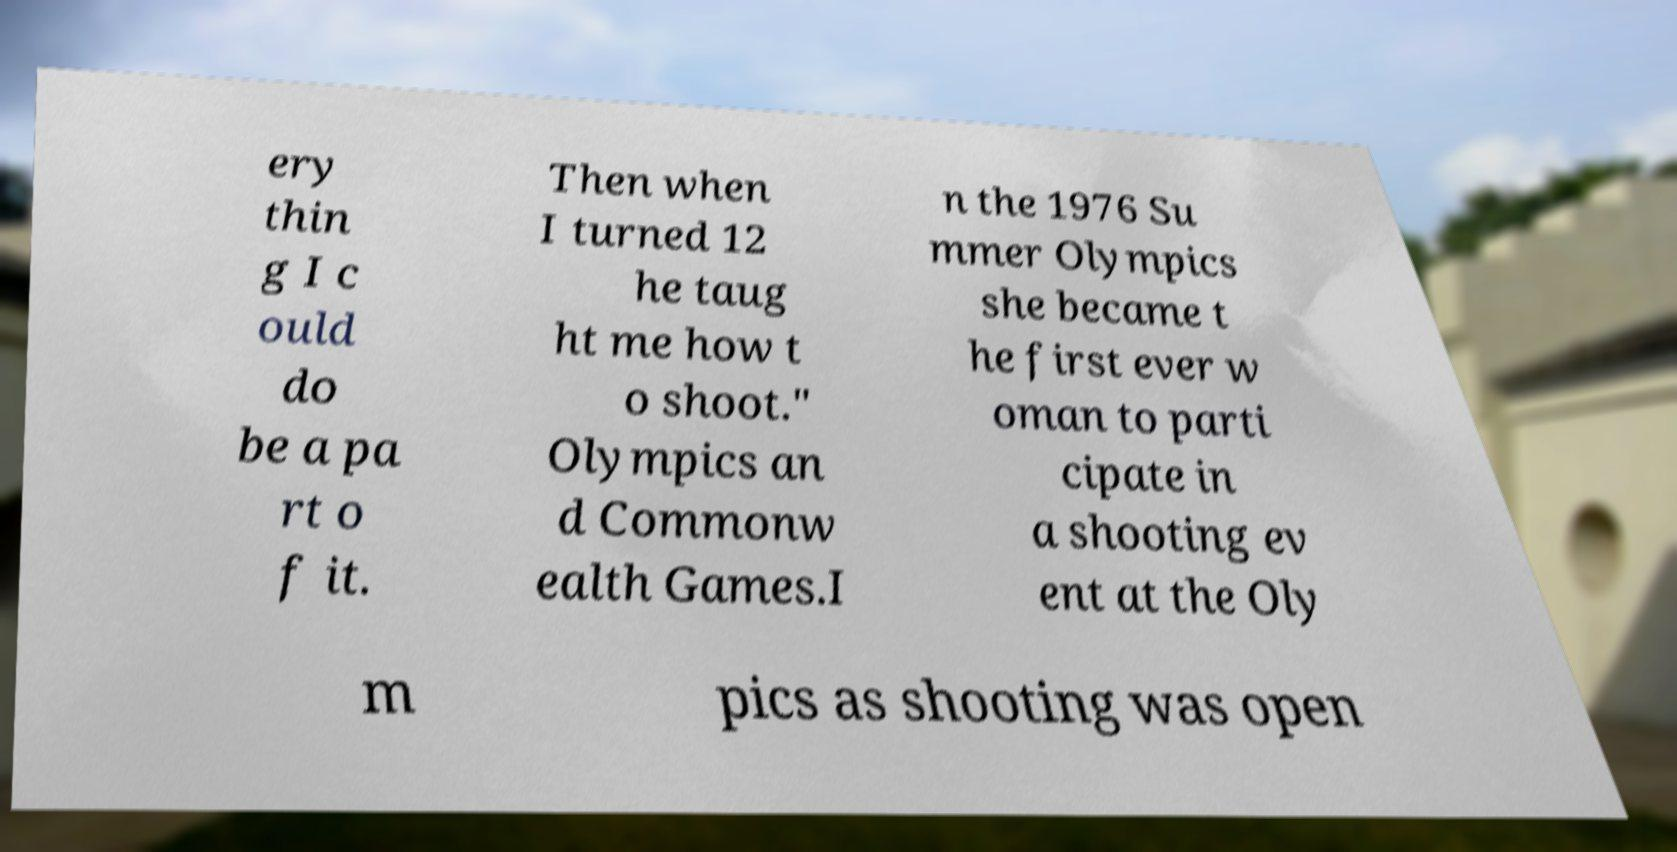I need the written content from this picture converted into text. Can you do that? ery thin g I c ould do be a pa rt o f it. Then when I turned 12 he taug ht me how t o shoot." Olympics an d Commonw ealth Games.I n the 1976 Su mmer Olympics she became t he first ever w oman to parti cipate in a shooting ev ent at the Oly m pics as shooting was open 